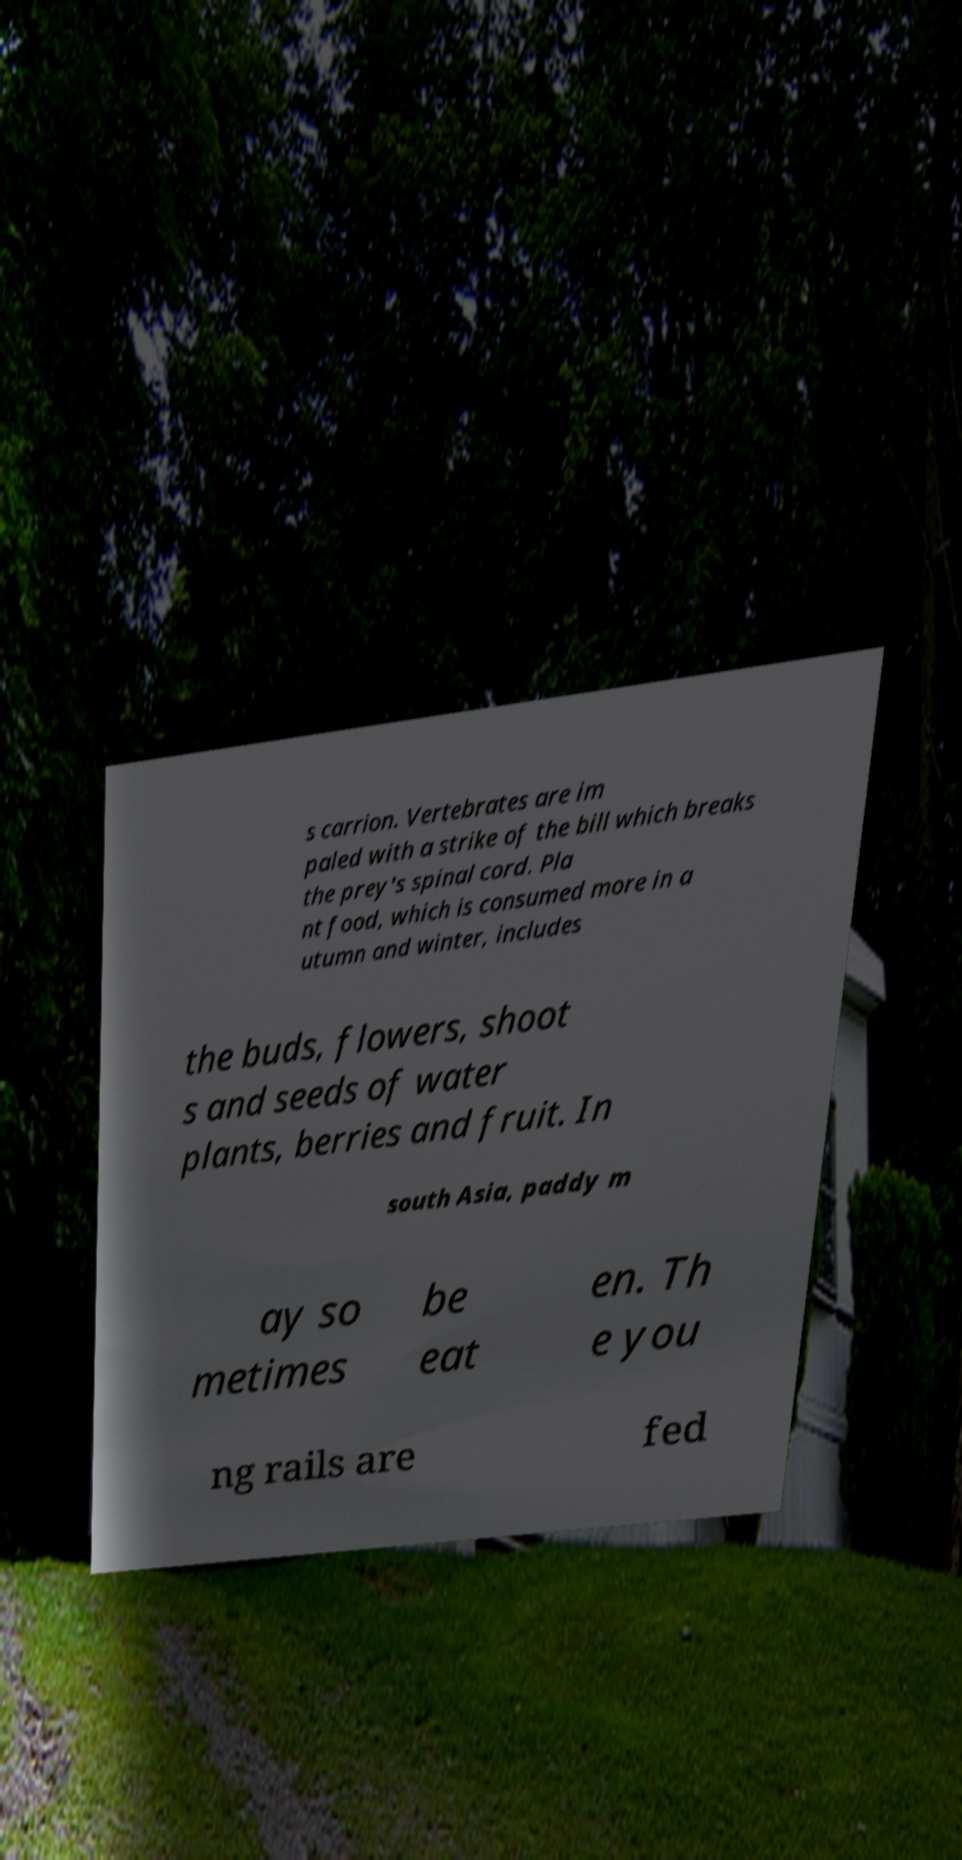Please read and relay the text visible in this image. What does it say? s carrion. Vertebrates are im paled with a strike of the bill which breaks the prey's spinal cord. Pla nt food, which is consumed more in a utumn and winter, includes the buds, flowers, shoot s and seeds of water plants, berries and fruit. In south Asia, paddy m ay so metimes be eat en. Th e you ng rails are fed 